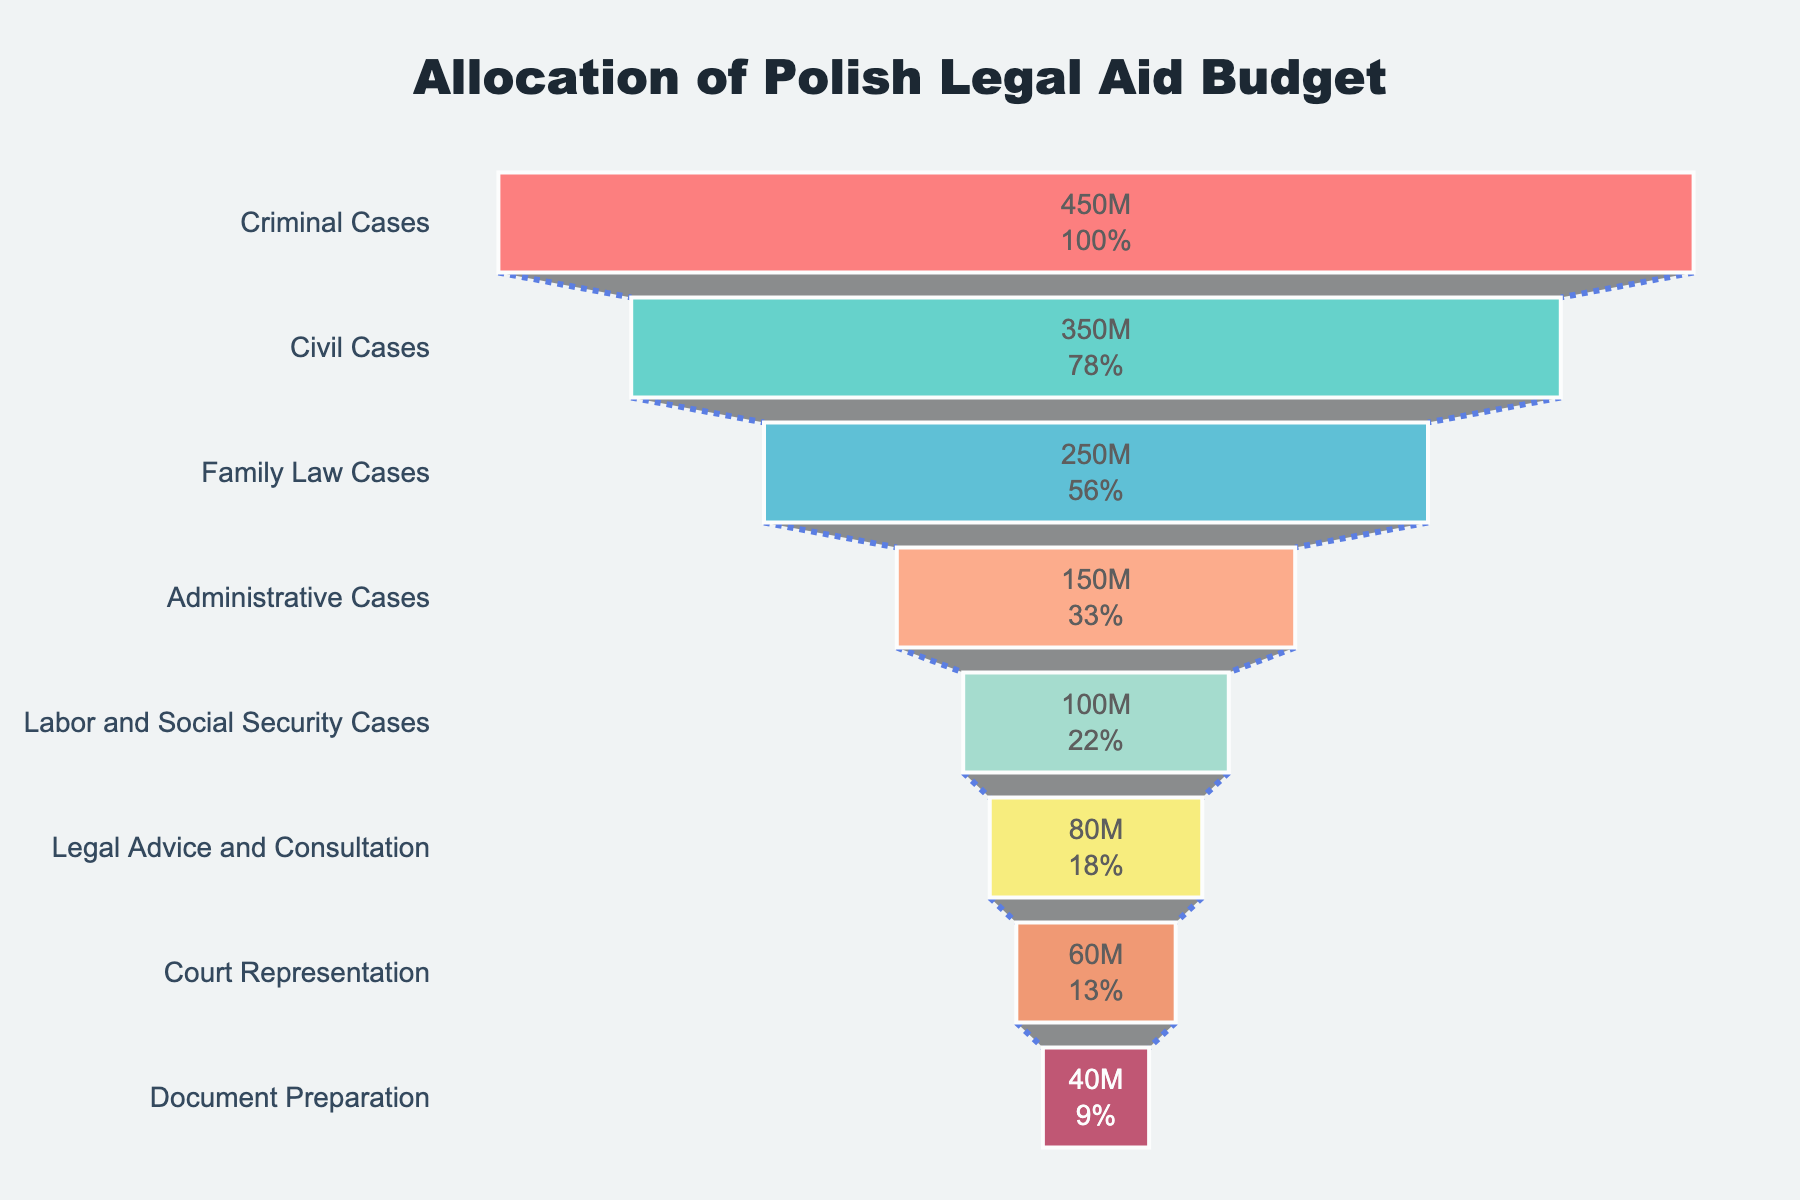What is the title of the funnel chart? The title is located at the top center of the chart and is usually the first thing one notices. It provides an overall description of what the chart is representing.
Answer: Allocation of Polish Legal Aid Budget Which category has the highest budget allocation? The category with the highest budget allocation is represented by the widest section at the top of the funnel chart.
Answer: Criminal Cases What is the budget allocation for Family Law Cases? Look at the section labeled "Family Law Cases" and refer to the value displayed inside that section.
Answer: 250,000,000 PLN How much more budget is allocated to Criminal Cases compared to Labor and Social Security Cases? Subtract the budget allocation for Labor and Social Security Cases from the budget allocation for Criminal Cases. 450,000,000 PLN - 100,000,000 PLN = 350,000,000 PLN
Answer: 350,000,000 PLN What is the total budget allocated to Civil Cases, Family Law Cases, and Administrative Cases? Add the budget allocations for Civil Cases, Family Law Cases, and Administrative Cases: 350,000,000 PLN + 250,000,000 PLN + 150,000,000 PLN = 750,000,000 PLN
Answer: 750,000,000 PLN How does the budget allocation for Legal Advice and Consultation compare to Document Preparation? Compare the budget allocations for the two categories by examining the values displayed: Legal Advice and Consultation (80,000,000 PLN) vs. Document Preparation (40,000,000 PLN).
Answer: Legal Advice and Consultation has a higher allocation What percentage of the total budget is allocated to Court Representation? First, sum up the total budget (sum of all categories), then divide the budget for Court Representation by this total and multiply by 100: (60,000,000 PLN / (450,000,000 PLN + 350,000,000 PLN + 250,000,000 PLN + 150,000,000 PLN + 100,000,000 PLN + 80,000,000 PLN + 60,000,000 PLN + 40,000,000 PLN)) * 100 ≈ 3.8%
Answer: 3.8% Which categories have a budget allocation less than 100,000,000 PLN? Identify the sections with budget allocations less than 100,000,000 PLN by looking at their values: Legal Advice and Consultation (80,000,000 PLN), Court Representation (60,000,000 PLN), Document Preparation (40,000,000 PLN).
Answer: Legal Advice and Consultation, Court Representation, Document Preparation If the budget for Criminal Cases were reduced by 50,000,000 PLN, what would the new allocation be? Subtract 50,000,000 PLN from the current allocation for Criminal Cases: 450,000,000 PLN - 50,000,000 PLN = 400,000,000 PLN
Answer: 400,000,000 PLN 